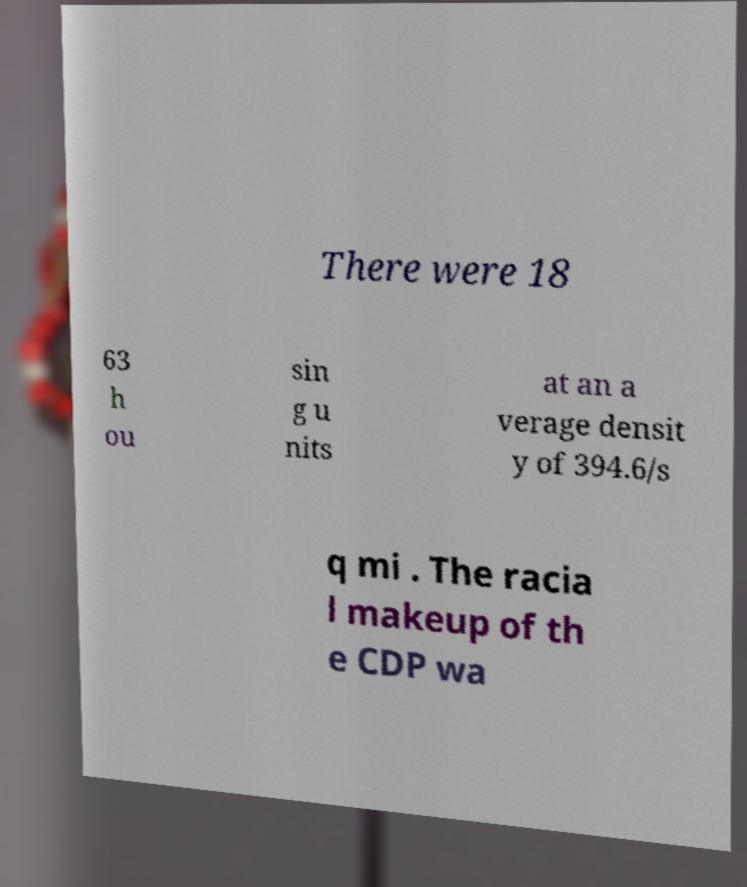For documentation purposes, I need the text within this image transcribed. Could you provide that? There were 18 63 h ou sin g u nits at an a verage densit y of 394.6/s q mi . The racia l makeup of th e CDP wa 